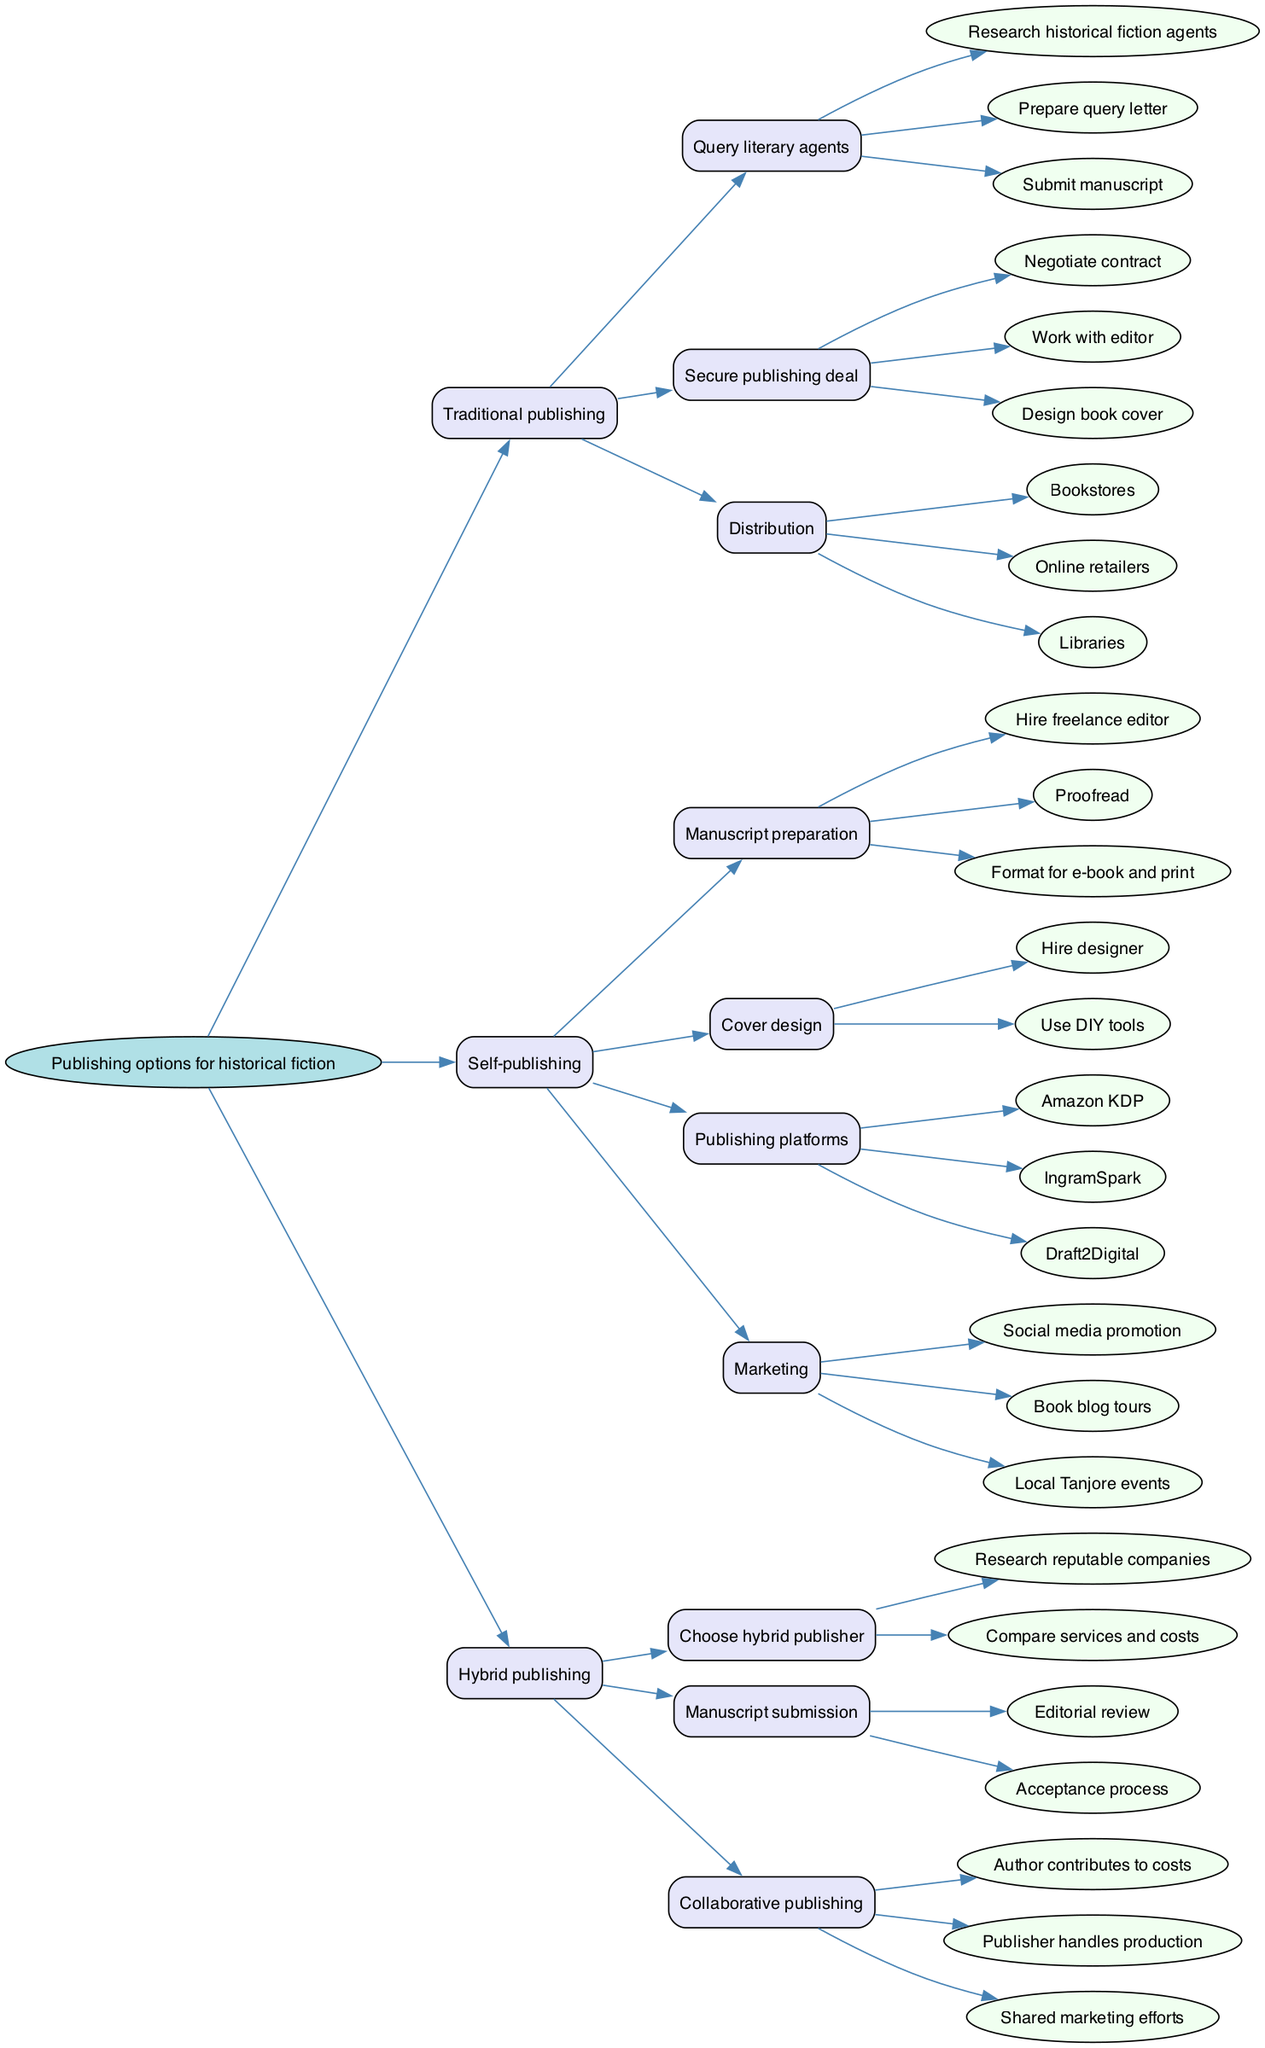What are the three main publishing options shown in the diagram? The diagram clearly shows three main options: Traditional publishing, Self-publishing, and Hybrid publishing. Each of these options is represented at the first level of branches from the root node, allowing for a straightforward identification of the key publishing routes available.
Answer: Traditional publishing, Self-publishing, Hybrid publishing How many actions are involved in the Traditional publishing process? The Traditional publishing branch consists of three main actions: Query literary agents, Secure publishing deal, and Distribution. Each branch then has its own sub-actions, so to find the total, you need to count the main branches, which gives you 3 actions.
Answer: 3 What is the first step in the Self-publishing process? The Self-publishing branch starts with Manuscript preparation, which is the first major action listed within that section. Tracking this directly from the diagram allows you to identify the sequential order of tasks clearly.
Answer: Manuscript preparation Which publishing option includes "Collaborative publishing"? The term "Collaborative publishing" is found in the Hybrid publishing section of the diagram. This indicates that among the various publishing options, only the Hybrid model encompasses this aspect, suggesting a shared effort between the author and publisher.
Answer: Hybrid publishing What types of marketing are associated with Self-publishing? Under the Self-publishing branch, the Marketing sub-branch cites three specific actions: Social media promotion, Book blog tours, and Local Tanjore events. This collection highlights the different promotional strategies that can be employed in self-publishing.
Answer: Social media promotion, Book blog tours, Local Tanjore events Name one publishing platform from the Self-publishing section. The diagram lists Amazon KDP, IngramSpark, and Draft2Digital as publishing platforms under the Self-publishing branch. Any one of these names can be used to satisfy the query, as they all represent viable options available for self-publishing.
Answer: Amazon KDP How does the process of "Query literary agents" begin in Traditional publishing? The starts with "Research historical fiction agents," followed by "Prepare query letter" before "Submit manuscript." This sequential breakdown provides a clear outline of the initial steps required to reach out to literary agents in the traditional publishing option.
Answer: Research historical fiction agents What is a key distinguishing feature of Hybrid publishing in the diagram? The key feature of Hybrid publishing, as depicted in the diagram, is that it combines elements from both traditional and self-publishing, specifically mentioning "Author contributes to costs" under the Collaborative publishing sub-branch. This indicates the unique nature of shared responsibilities in this model.
Answer: Author contributes to costs 